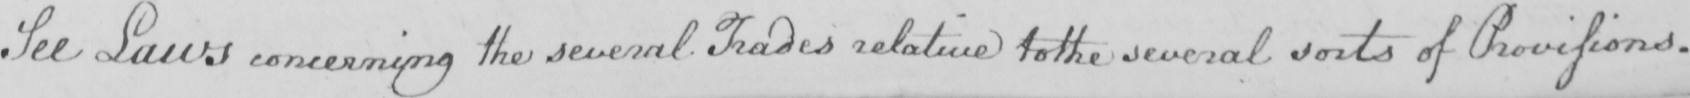Can you tell me what this handwritten text says? See Laws concerning the several Trades relative to the several sorts of Provisions. 